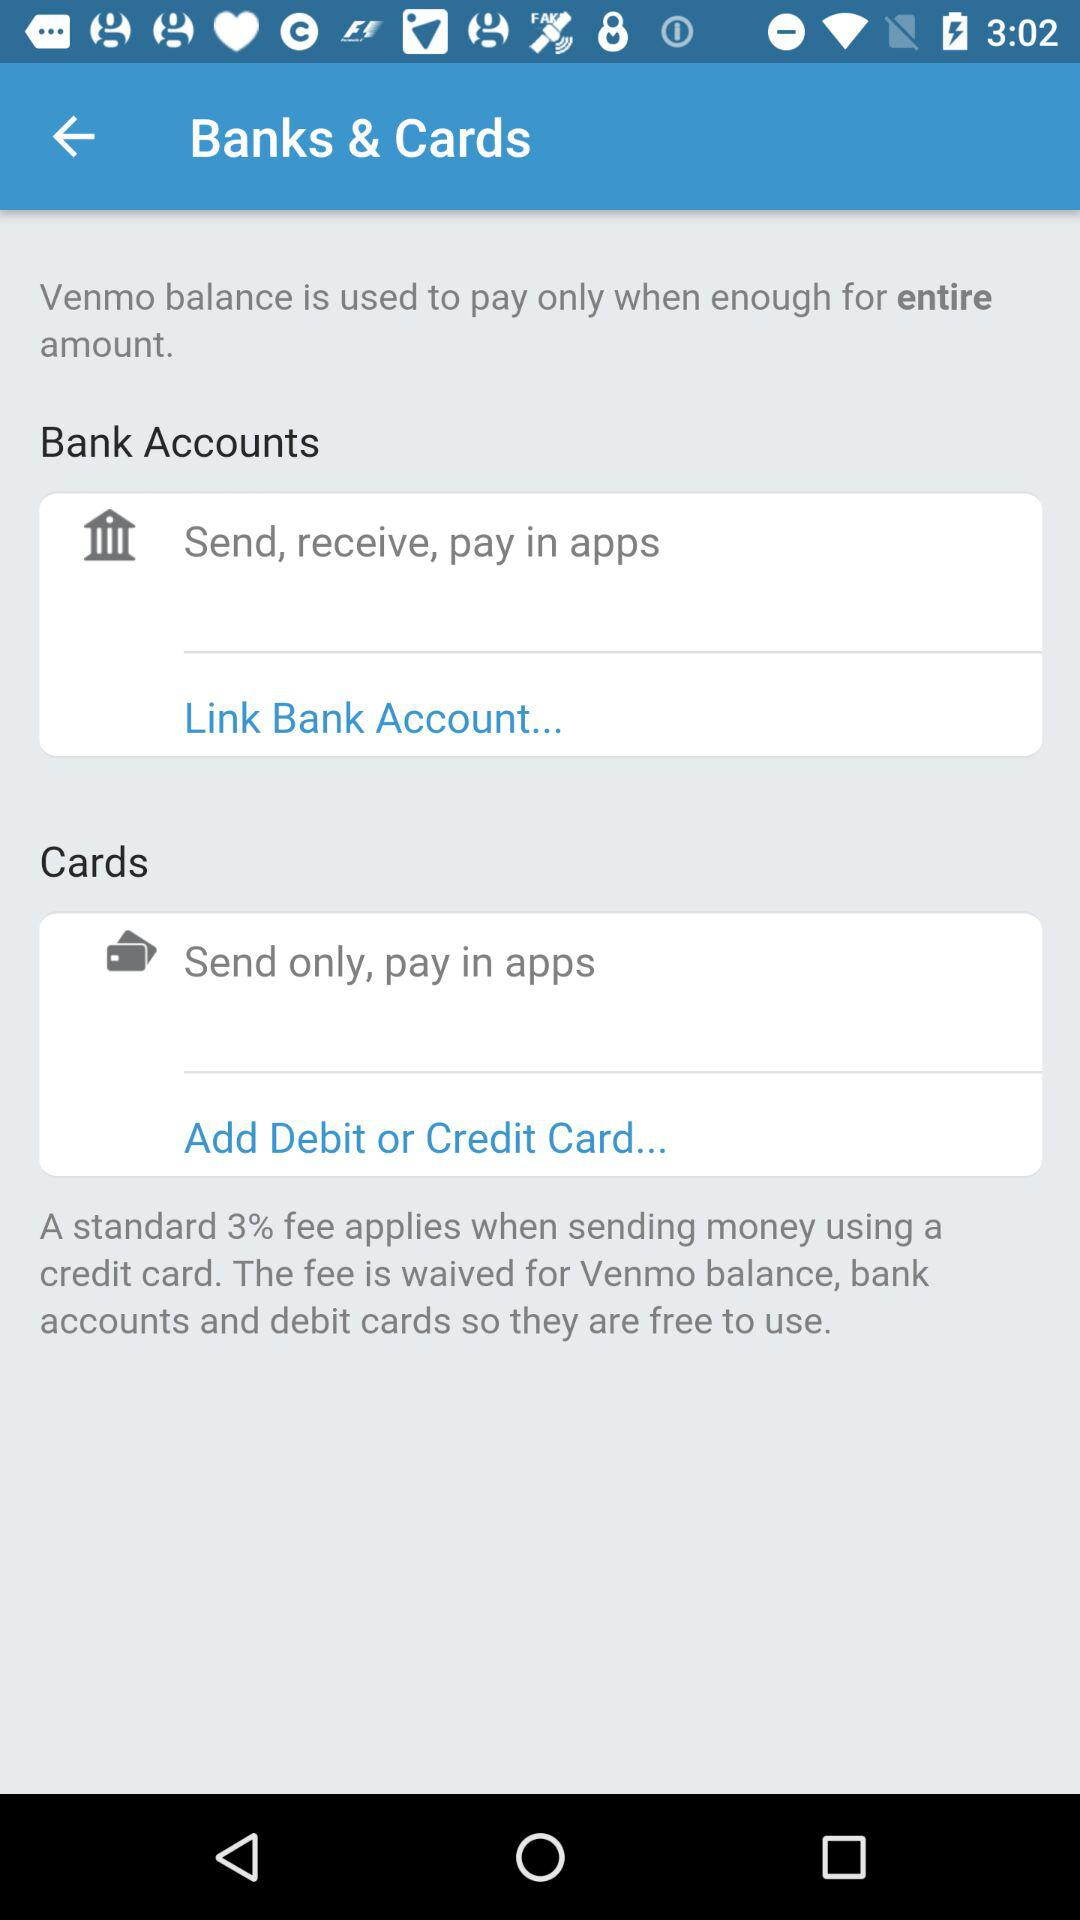What is the standard fee that applies for sending money using a credit card? The standard fee is 3%. 